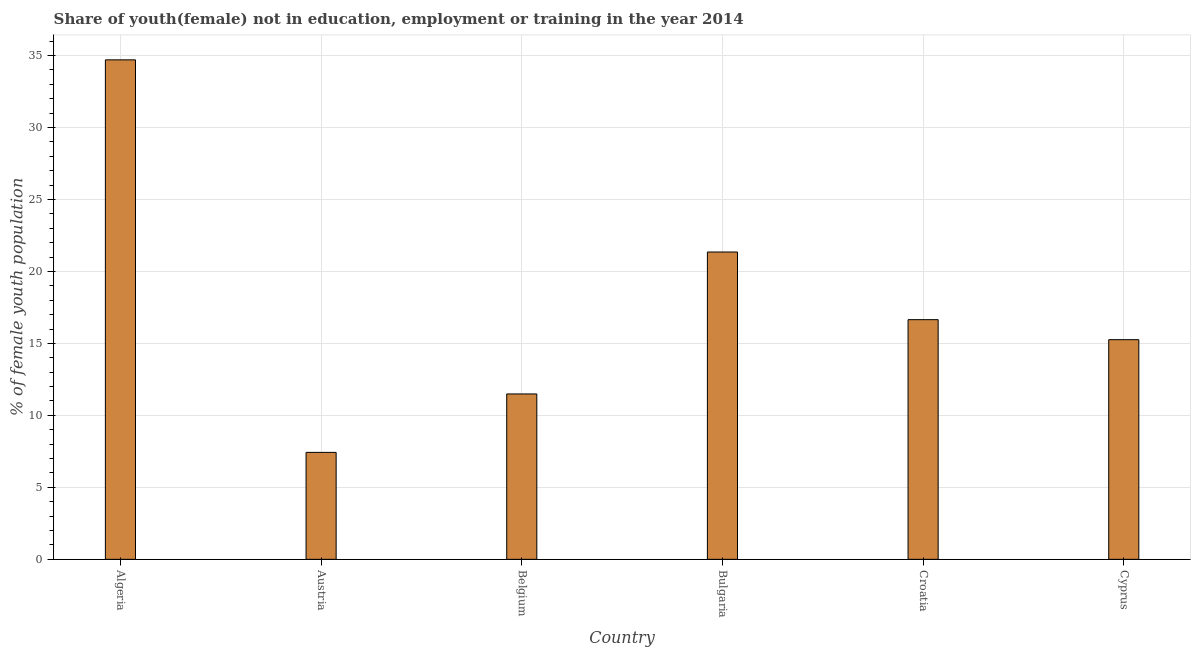Does the graph contain any zero values?
Your response must be concise. No. What is the title of the graph?
Ensure brevity in your answer.  Share of youth(female) not in education, employment or training in the year 2014. What is the label or title of the X-axis?
Offer a terse response. Country. What is the label or title of the Y-axis?
Offer a terse response. % of female youth population. What is the unemployed female youth population in Algeria?
Keep it short and to the point. 34.7. Across all countries, what is the maximum unemployed female youth population?
Give a very brief answer. 34.7. Across all countries, what is the minimum unemployed female youth population?
Provide a short and direct response. 7.43. In which country was the unemployed female youth population maximum?
Offer a terse response. Algeria. What is the sum of the unemployed female youth population?
Keep it short and to the point. 106.88. What is the difference between the unemployed female youth population in Croatia and Cyprus?
Provide a short and direct response. 1.39. What is the average unemployed female youth population per country?
Give a very brief answer. 17.81. What is the median unemployed female youth population?
Offer a very short reply. 15.95. What is the ratio of the unemployed female youth population in Algeria to that in Cyprus?
Offer a very short reply. 2.27. Is the difference between the unemployed female youth population in Croatia and Cyprus greater than the difference between any two countries?
Make the answer very short. No. What is the difference between the highest and the second highest unemployed female youth population?
Keep it short and to the point. 13.35. Is the sum of the unemployed female youth population in Austria and Bulgaria greater than the maximum unemployed female youth population across all countries?
Ensure brevity in your answer.  No. What is the difference between the highest and the lowest unemployed female youth population?
Your response must be concise. 27.27. Are all the bars in the graph horizontal?
Offer a very short reply. No. What is the difference between two consecutive major ticks on the Y-axis?
Make the answer very short. 5. What is the % of female youth population in Algeria?
Provide a short and direct response. 34.7. What is the % of female youth population in Austria?
Provide a succinct answer. 7.43. What is the % of female youth population of Belgium?
Ensure brevity in your answer.  11.49. What is the % of female youth population in Bulgaria?
Keep it short and to the point. 21.35. What is the % of female youth population of Croatia?
Provide a succinct answer. 16.65. What is the % of female youth population in Cyprus?
Offer a terse response. 15.26. What is the difference between the % of female youth population in Algeria and Austria?
Your answer should be very brief. 27.27. What is the difference between the % of female youth population in Algeria and Belgium?
Your answer should be very brief. 23.21. What is the difference between the % of female youth population in Algeria and Bulgaria?
Ensure brevity in your answer.  13.35. What is the difference between the % of female youth population in Algeria and Croatia?
Ensure brevity in your answer.  18.05. What is the difference between the % of female youth population in Algeria and Cyprus?
Your answer should be very brief. 19.44. What is the difference between the % of female youth population in Austria and Belgium?
Offer a terse response. -4.06. What is the difference between the % of female youth population in Austria and Bulgaria?
Offer a very short reply. -13.92. What is the difference between the % of female youth population in Austria and Croatia?
Offer a terse response. -9.22. What is the difference between the % of female youth population in Austria and Cyprus?
Your answer should be very brief. -7.83. What is the difference between the % of female youth population in Belgium and Bulgaria?
Your response must be concise. -9.86. What is the difference between the % of female youth population in Belgium and Croatia?
Give a very brief answer. -5.16. What is the difference between the % of female youth population in Belgium and Cyprus?
Your answer should be compact. -3.77. What is the difference between the % of female youth population in Bulgaria and Cyprus?
Offer a very short reply. 6.09. What is the difference between the % of female youth population in Croatia and Cyprus?
Make the answer very short. 1.39. What is the ratio of the % of female youth population in Algeria to that in Austria?
Provide a succinct answer. 4.67. What is the ratio of the % of female youth population in Algeria to that in Belgium?
Ensure brevity in your answer.  3.02. What is the ratio of the % of female youth population in Algeria to that in Bulgaria?
Your response must be concise. 1.62. What is the ratio of the % of female youth population in Algeria to that in Croatia?
Offer a terse response. 2.08. What is the ratio of the % of female youth population in Algeria to that in Cyprus?
Provide a short and direct response. 2.27. What is the ratio of the % of female youth population in Austria to that in Belgium?
Your answer should be very brief. 0.65. What is the ratio of the % of female youth population in Austria to that in Bulgaria?
Give a very brief answer. 0.35. What is the ratio of the % of female youth population in Austria to that in Croatia?
Your answer should be compact. 0.45. What is the ratio of the % of female youth population in Austria to that in Cyprus?
Your answer should be very brief. 0.49. What is the ratio of the % of female youth population in Belgium to that in Bulgaria?
Keep it short and to the point. 0.54. What is the ratio of the % of female youth population in Belgium to that in Croatia?
Keep it short and to the point. 0.69. What is the ratio of the % of female youth population in Belgium to that in Cyprus?
Provide a short and direct response. 0.75. What is the ratio of the % of female youth population in Bulgaria to that in Croatia?
Keep it short and to the point. 1.28. What is the ratio of the % of female youth population in Bulgaria to that in Cyprus?
Make the answer very short. 1.4. What is the ratio of the % of female youth population in Croatia to that in Cyprus?
Give a very brief answer. 1.09. 